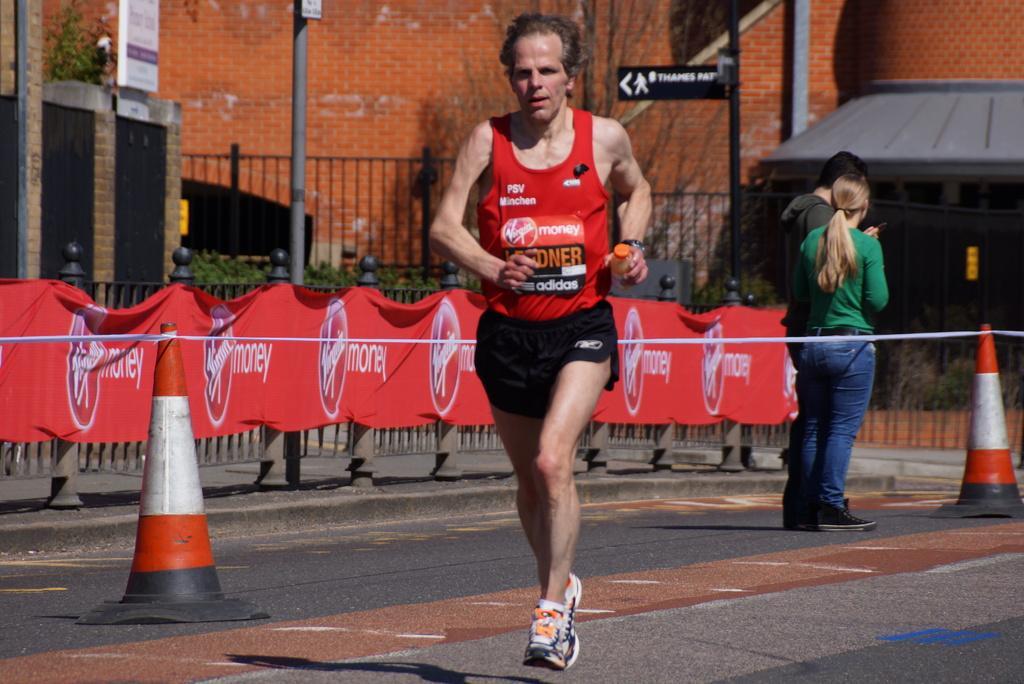Can you describe this image briefly? In this picture we can see a man holding a bottle with his hand and running on the ground, and at the back of him we can see two people standing, traffic cones, rope, banners, fences, plants, trees, wall, name board, poles, posters and some objects. 